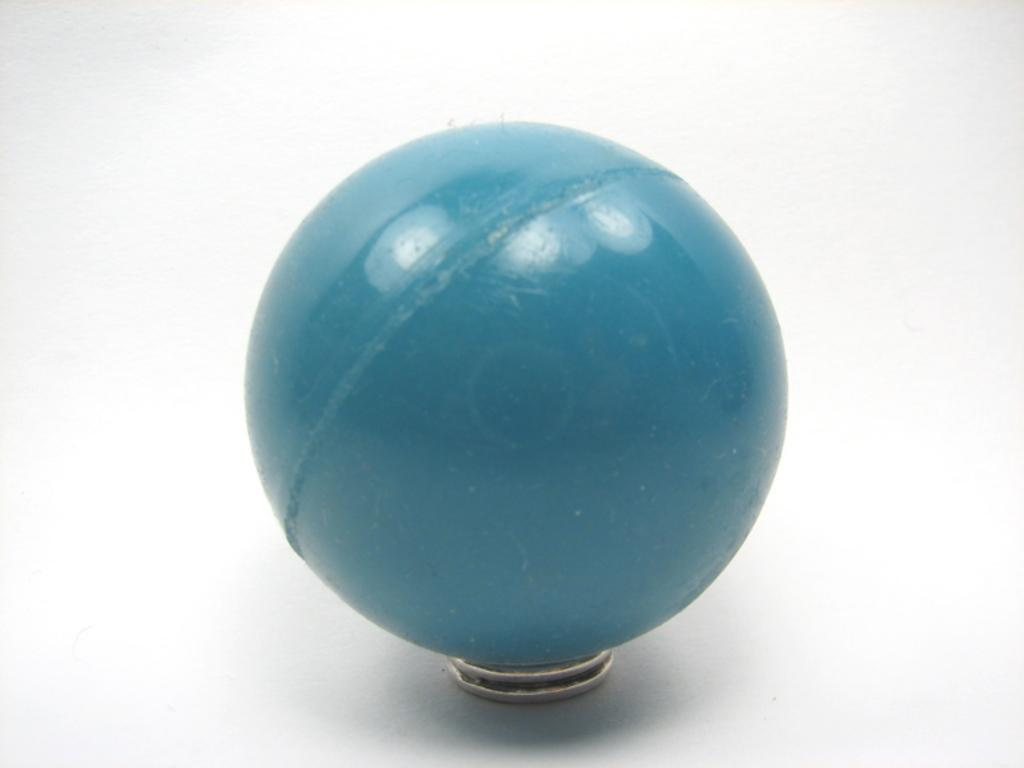What object is present in the image? There is a ball in the image. Where is the ball located? The ball is placed on a table. What type of watch is the ball sinking into in the image? There is no watch or quicksand present in the image; it only features a ball placed on a table. 